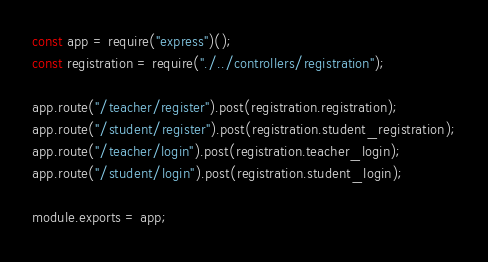<code> <loc_0><loc_0><loc_500><loc_500><_JavaScript_>const app = require("express")();
const registration = require("./../controllers/registration");

app.route("/teacher/register").post(registration.registration);
app.route("/student/register").post(registration.student_registration);
app.route("/teacher/login").post(registration.teacher_login);
app.route("/student/login").post(registration.student_login);

module.exports = app;
</code> 